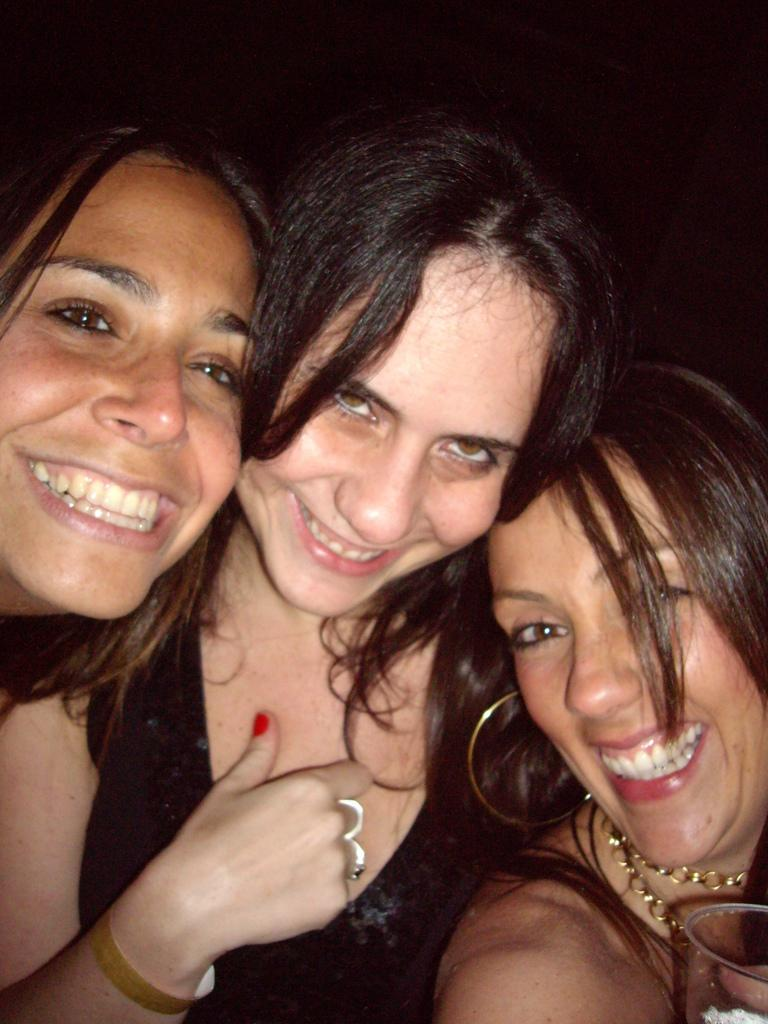How many women are in the image? There are three women in the image. What is the appearance of one of the women's dresses? One woman is wearing a black dress. What is one of the women holding in her hand? One woman is holding a glass in her hand. What type of boat can be seen in the image? There is no boat present in the image. How many trucks are visible in the image? There are no trucks present in the image. 